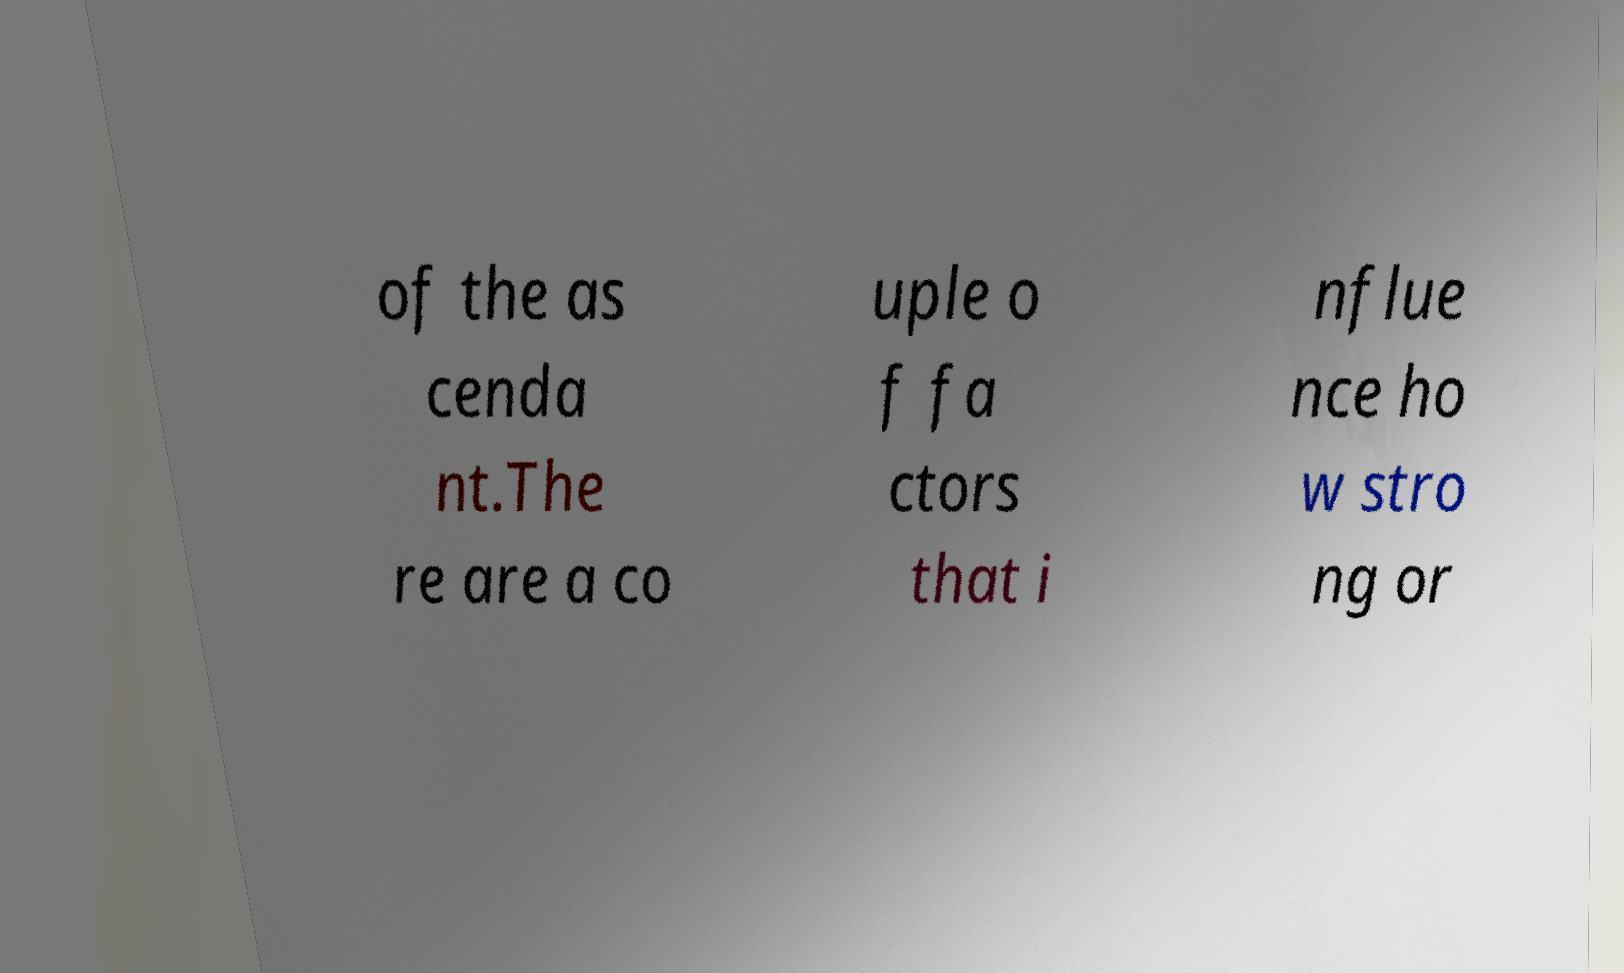Can you read and provide the text displayed in the image?This photo seems to have some interesting text. Can you extract and type it out for me? of the as cenda nt.The re are a co uple o f fa ctors that i nflue nce ho w stro ng or 